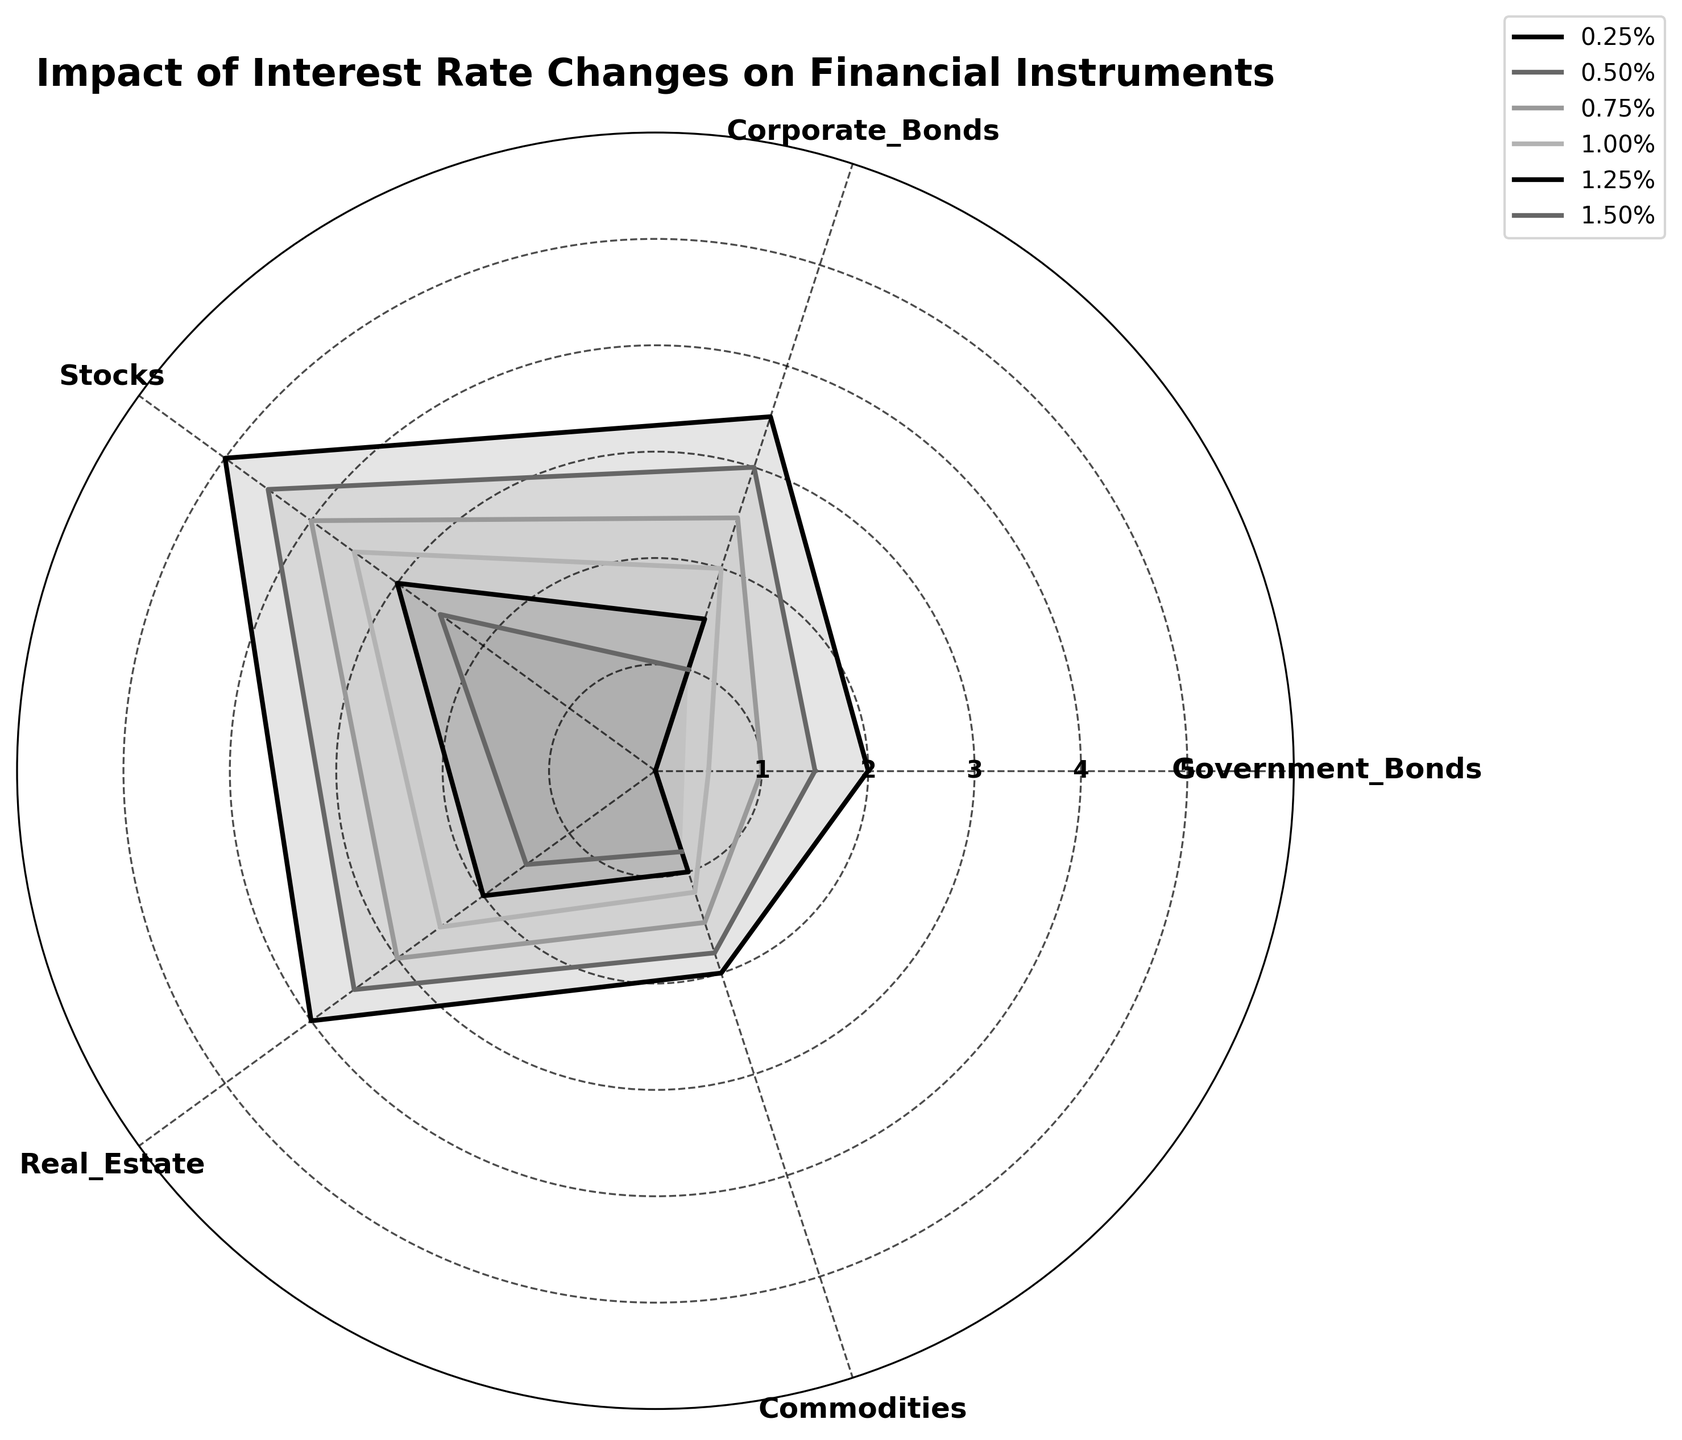What is the title of the chart? Look at the top of the radar chart. The title is usually displayed prominently and describes what the chart is about.
Answer: Impact of Interest Rate Changes on Financial Instruments Which financial instrument is least affected by a 1.00% interest rate? Locate the line corresponding to 1.00% interest rate on the radar chart and check the values for each financial instrument. The instrument with the smallest value is the least affected.
Answer: Government Bonds How does the impact on Corporate Bonds change between 0.25% and 1.50% interest rates? Compare the values for Corporate Bonds at 0.25% and 1.50% interest rates. Look at the starting and ending points and note the difference.
Answer: Decreases from 3.5 to 1 What financial instrument has the highest impact value at an interest rate of 0.50%? Identify the line for the 0.50% interest rate and compare the values for all financial instruments. The highest point indicates the maximum impact.
Answer: Stocks Which financial instrument shows the most variation across different interest rates? Examine the spread of values for each financial instrument. The one with the largest range between its highest and lowest values shows the most variation.
Answer: Stocks At what interest rate do Real Estate and Commodities have the same impact value? Locate points where the values for Real Estate and Commodities overlap. Check the corresponding interest rate for that point.
Answer: 1.50% Does the impact on Government Bonds ever go negative, and if so, at what interest rate? Check the values for Government Bonds across all interest rates. Identify if any value is below 0 and note the corresponding interest rate.
Answer: Yes, at 1.50% How does the impact on Stocks compare to Real Estate at an interest rate of 0.75%? Find the values for Stocks and Real Estate at 0.75% interest rate and compare them.
Answer: Stocks: 4, Real Estate: 3 Which interest rate has the smallest average impact across all financial instruments? Calculate the average impact for each interest rate by summing the values for all financial instruments and dividing by five. Identify the smallest average.
Answer: 1.50% At 1.25% interest rate, which financial instrument is most resilient (least impacted)? Find the 1.25% interest rate line and identify the financial instrument with the highest value, indicating it is least impacted or most resilient.
Answer: Government Bonds 